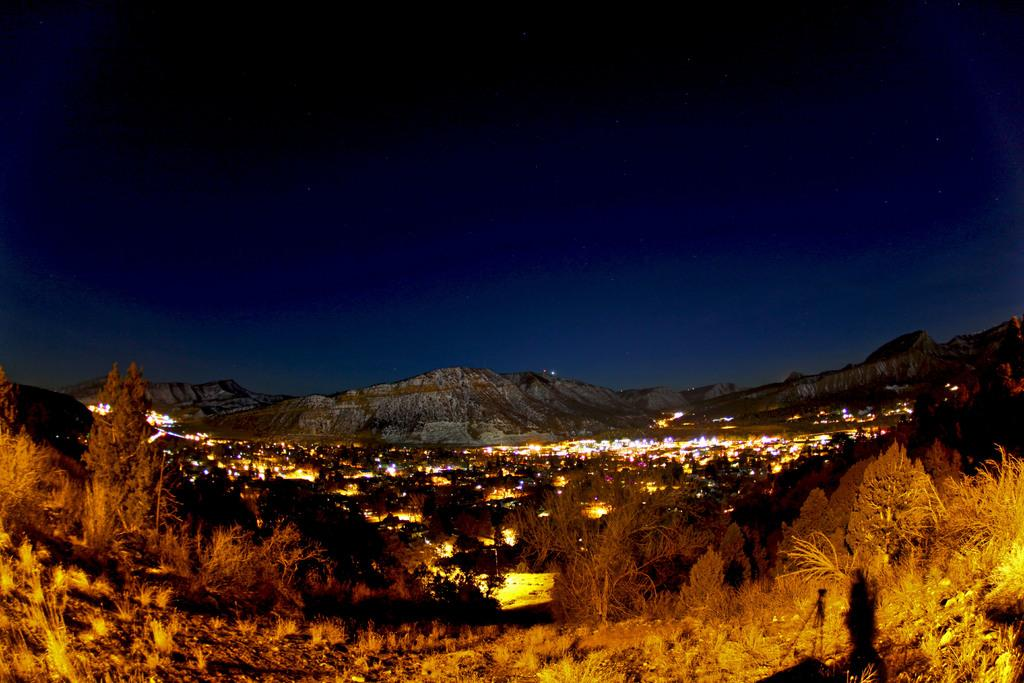What can be seen in the foreground of the image? There are plants and trees in the foreground of the image. What is visible in the background of the image? There is a city and mountains visible in the background of the image. How would you describe the sky in the background of the image? The sky is dark in the background of the image. What type of current is flowing through the mountains in the image? There is no indication of a current in the image; it features plants, trees, a city, mountains, and a dark sky. How many partners are visible in the image? There are no people or partners present in the image. 